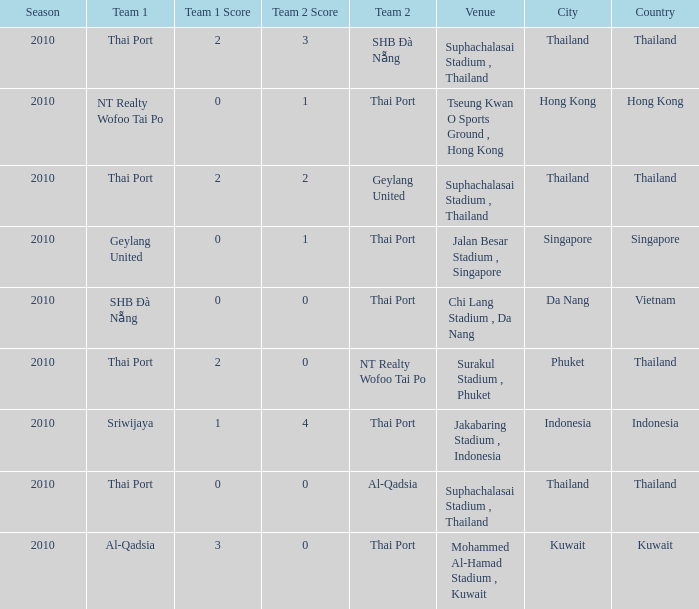Parse the full table. {'header': ['Season', 'Team 1', 'Team 1 Score', 'Team 2 Score', 'Team 2', 'Venue', 'City', 'Country'], 'rows': [['2010', 'Thai Port', '2', '3', 'SHB Ðà Nẵng', 'Suphachalasai Stadium , Thailand', 'Thailand', 'Thailand'], ['2010', 'NT Realty Wofoo Tai Po', '0', '1', 'Thai Port', 'Tseung Kwan O Sports Ground , Hong Kong', 'Hong Kong', 'Hong Kong'], ['2010', 'Thai Port', '2', '2', 'Geylang United', 'Suphachalasai Stadium , Thailand', 'Thailand', 'Thailand'], ['2010', 'Geylang United', '0', '1', 'Thai Port', 'Jalan Besar Stadium , Singapore', 'Singapore', 'Singapore'], ['2010', 'SHB Ðà Nẵng', '0', '0', 'Thai Port', 'Chi Lang Stadium , Da Nang', 'Da Nang', 'Vietnam'], ['2010', 'Thai Port', '2', '0', 'NT Realty Wofoo Tai Po', 'Surakul Stadium , Phuket', 'Phuket', 'Thailand'], ['2010', 'Sriwijaya', '1', '4', 'Thai Port', 'Jakabaring Stadium , Indonesia', 'Indonesia', 'Indonesia'], ['2010', 'Thai Port', '0', '0', 'Al-Qadsia', 'Suphachalasai Stadium , Thailand', 'Thailand', 'Thailand'], ['2010', 'Al-Qadsia', '3', '0', 'Thai Port', 'Mohammed Al-Hamad Stadium , Kuwait', 'Kuwait', 'Kuwait']]} Which venue was used for the game whose score was 2:3? Suphachalasai Stadium , Thailand. 